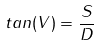<formula> <loc_0><loc_0><loc_500><loc_500>t a n ( V ) = \frac { S } { D }</formula> 